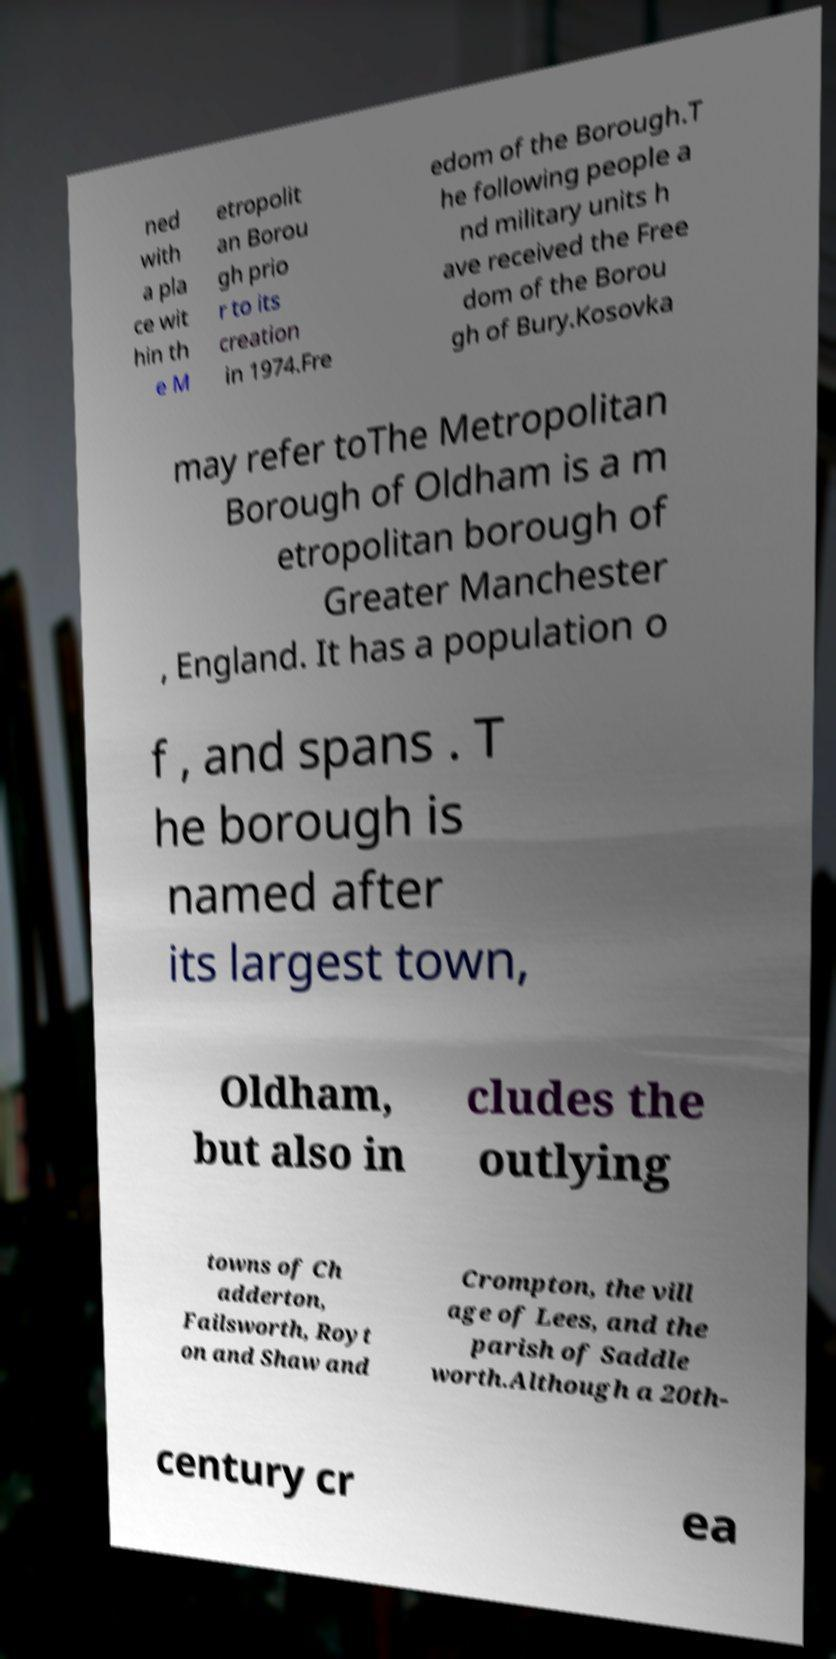Can you accurately transcribe the text from the provided image for me? ned with a pla ce wit hin th e M etropolit an Borou gh prio r to its creation in 1974.Fre edom of the Borough.T he following people a nd military units h ave received the Free dom of the Borou gh of Bury.Kosovka may refer toThe Metropolitan Borough of Oldham is a m etropolitan borough of Greater Manchester , England. It has a population o f , and spans . T he borough is named after its largest town, Oldham, but also in cludes the outlying towns of Ch adderton, Failsworth, Royt on and Shaw and Crompton, the vill age of Lees, and the parish of Saddle worth.Although a 20th- century cr ea 